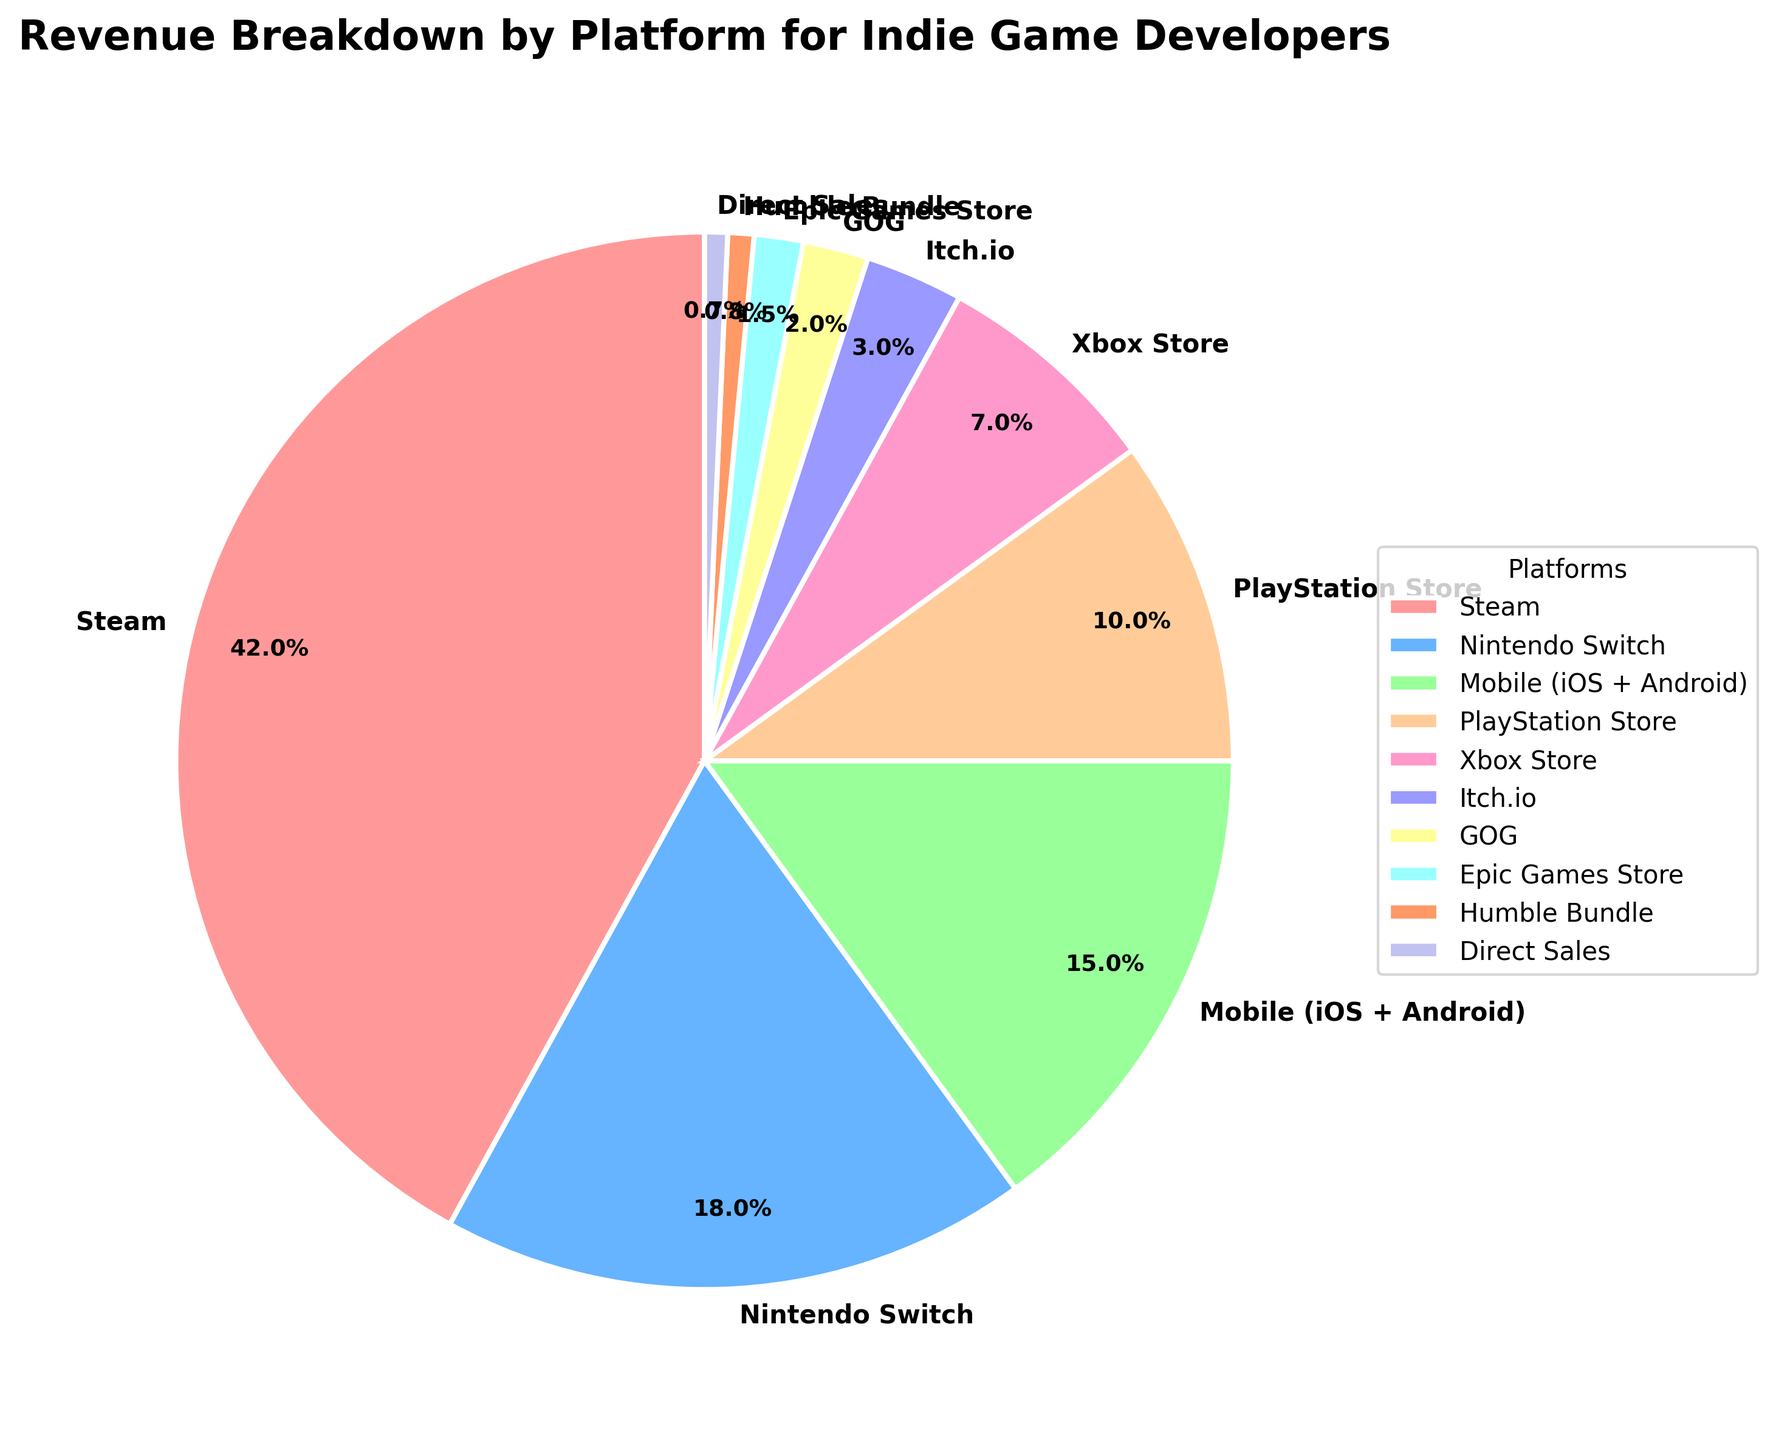What's the largest revenue contributor? The pie chart shows different platforms, each marked with their respective revenue percentage. The platform with the largest percentage slice will be the largest contributor. In this case, Steam is the largest revenue contributor with 42%.
Answer: Steam What's the smallest revenue contributor? Look for the smallest slice in the pie chart. The platform with the lowest revenue percentage is Epic Games Store with 0.7%.
Answer: Direct Sales How much more revenue does Steam generate compared to Mobile (iOS + Android)? Steam has 42% and Mobile has 15%. Subtract the Mobile percentage from the Steam percentage to find the difference (42% - 15% = 27%).
Answer: 27% Which platforms contribute less than 5% of the revenue individually? Identify all slices in the pie chart with a label showing less than 5%. The platforms with less than 5% individually are Itch.io (3%), GOG (2%), Epic Games Store (1.5%), Humble Bundle (0.8%), and Direct Sales (0.7%).
Answer: Itch.io, GOG, Epic Games Store, Humble Bundle, Direct Sales Are there more platforms contributing above or below 10% of the total revenue? Count the number of platforms above 10% and those below 10%. Steam (42%), Nintendo Switch (18%), and Mobile (15%) are above 10%; PlayStation Store (10%), Xbox Store (7%), Itch.io (3%), GOG (2%), Epic Games Store (1.5%), Humble Bundle (0.8%), and Direct Sales (0.7%) are below 10%. There are 3 platforms above 10% and 7 below 10%.
Answer: Below 10% Which platform has the second highest revenue and how much is it? Check the pie chart slices and find the second largest percentage label after Steam (42%). The second highest is Nintendo Switch with 18%.
Answer: Nintendo Switch, 18% How much combined revenue do the Xbox Store and Direct Sales generate? Add the percentages of Xbox Store and Direct Sales (7% + 0.7% = 7.7%).
Answer: 7.7% If you combine the revenues from the smallest five platforms, what is their total contribution? The smallest five platforms are Direct Sales (0.7%), Humble Bundle (0.8%), Epic Games Store (1.5%), GOG (2%), and Itch.io (3%). Adding them together gives (0.7% + 0.8% + 1.5% + 2% + 3% = 8%).
Answer: 8% What is the difference in revenue between the PlayStation Store and the Nintendo Switch? Subtract the PlayStation Store percentage from the Nintendo Switch percentage (18% - 10% = 8%).
Answer: 8% Which platform generates more revenue: Nintendo Switch or Mobile (iOS + Android)? Compare the two percentages. Nintendo Switch generates 18% and Mobile generates 15%. So, Nintendo Switch generates more revenue.
Answer: Nintendo Switch 